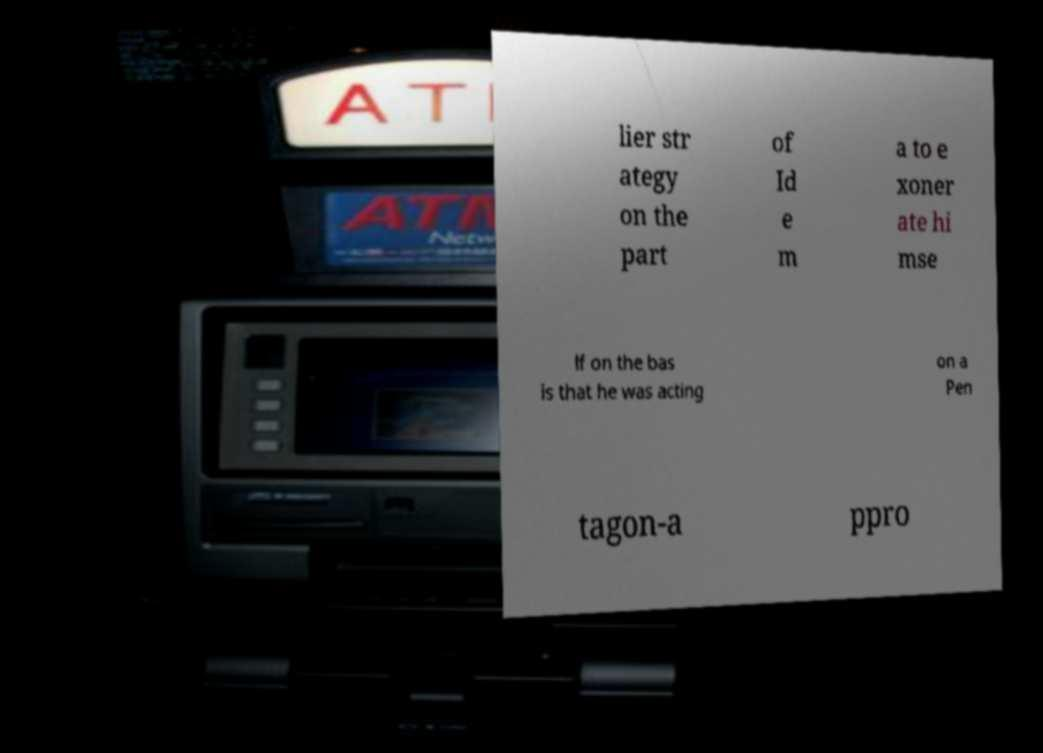There's text embedded in this image that I need extracted. Can you transcribe it verbatim? lier str ategy on the part of Id e m a to e xoner ate hi mse lf on the bas is that he was acting on a Pen tagon-a ppro 